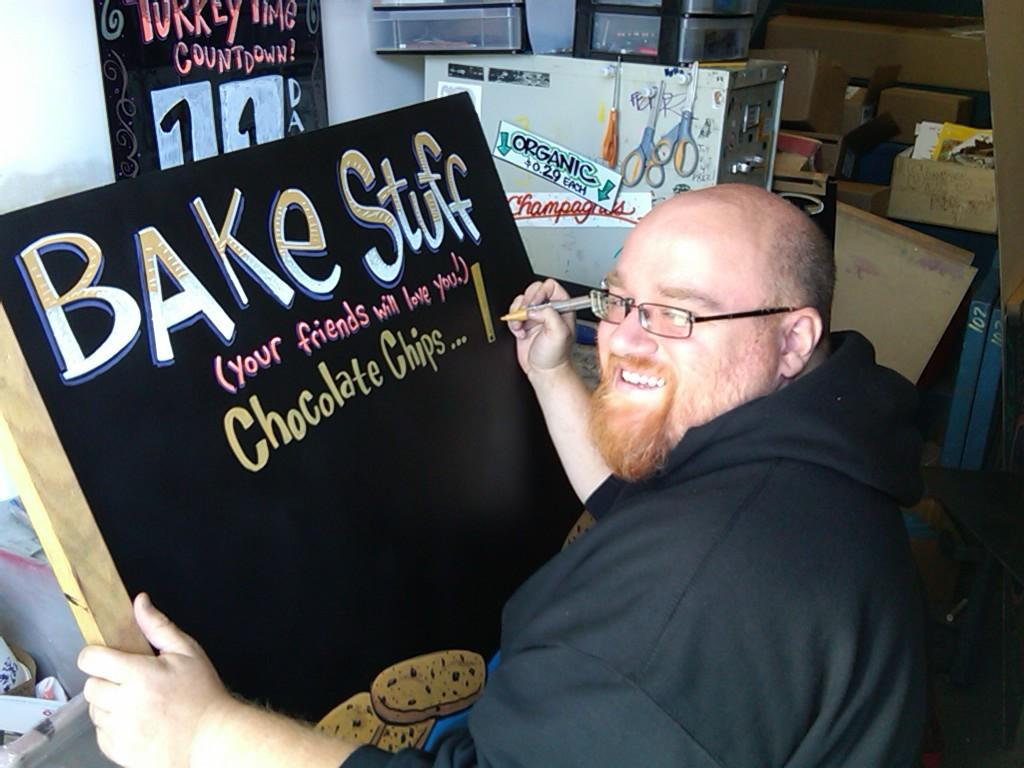<image>
Give a short and clear explanation of the subsequent image. a man painting on a sign that says 'bake stuff' on it 